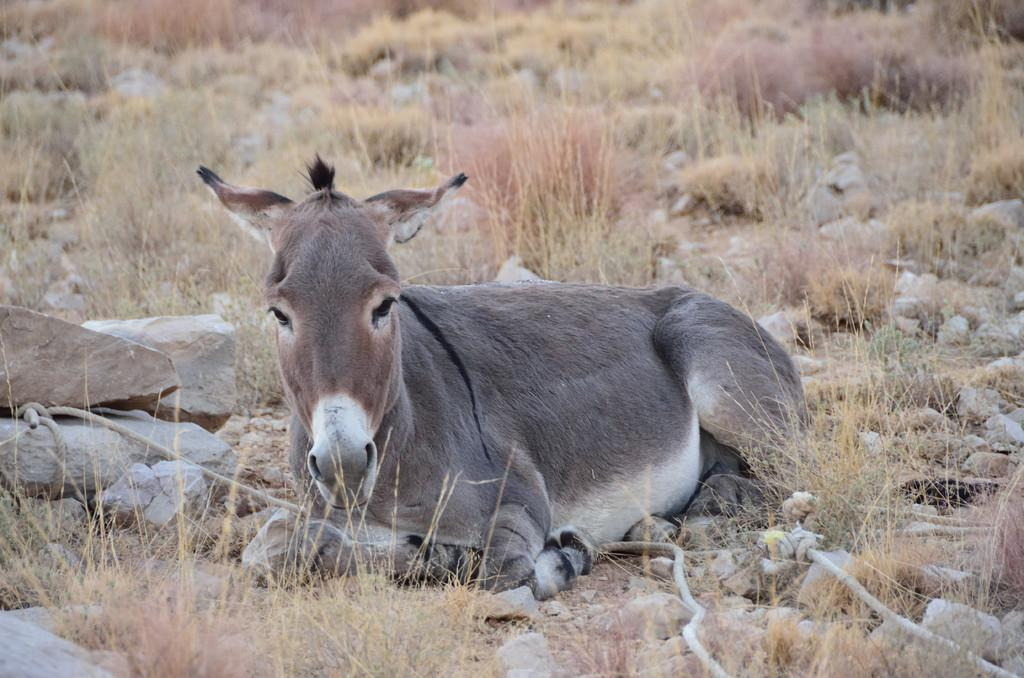What animal is in the image? There is a donkey in the image. What is the donkey doing in the image? The donkey is sitting on the ground. What type of terrain is visible at the bottom of the image? Rocks and dry grass are visible at the bottom of the image. What type of bells can be heard ringing in the image? There are no bells present in the image, and therefore no sound can be heard. 